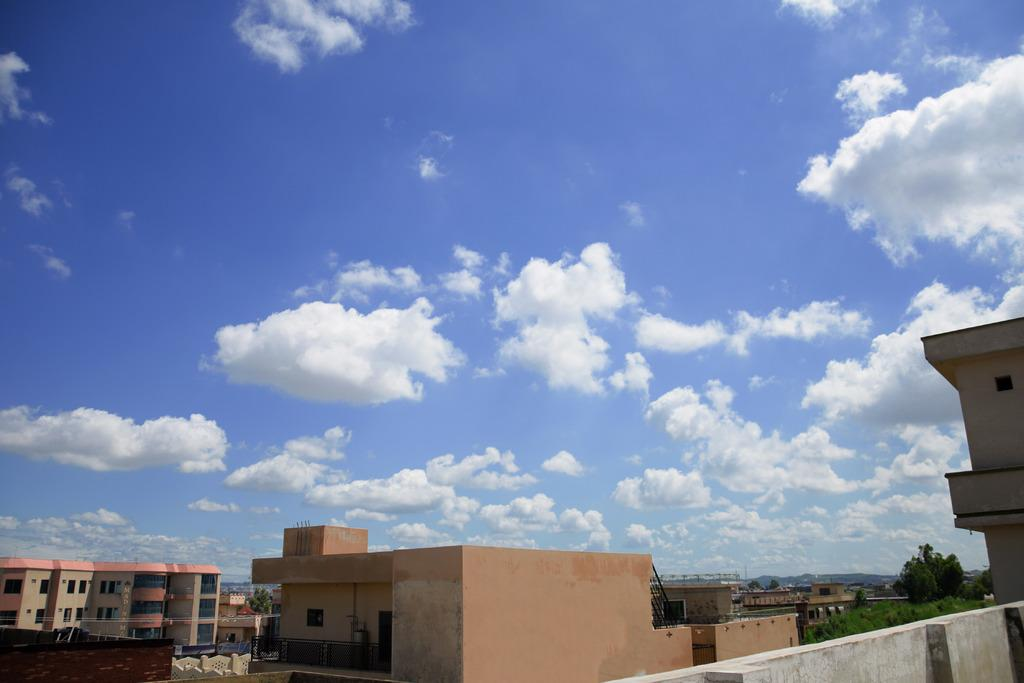What type of structures can be seen in the image? There are buildings in the image. What other natural elements are present in the image? There are trees in the image. What can be seen on the right side of the image? There are hills on the right side of the image. What is visible at the top of the image? The sky is visible at the top of the image. What can be observed in the sky? Clouds are present in the sky. What type of giants can be seen battling on the hills in the image? There are no giants or any battle depicted in the image; it features buildings, trees, hills, and a sky with clouds. What is the aftermath of the battle in the image? There is no battle or aftermath present in the image. 